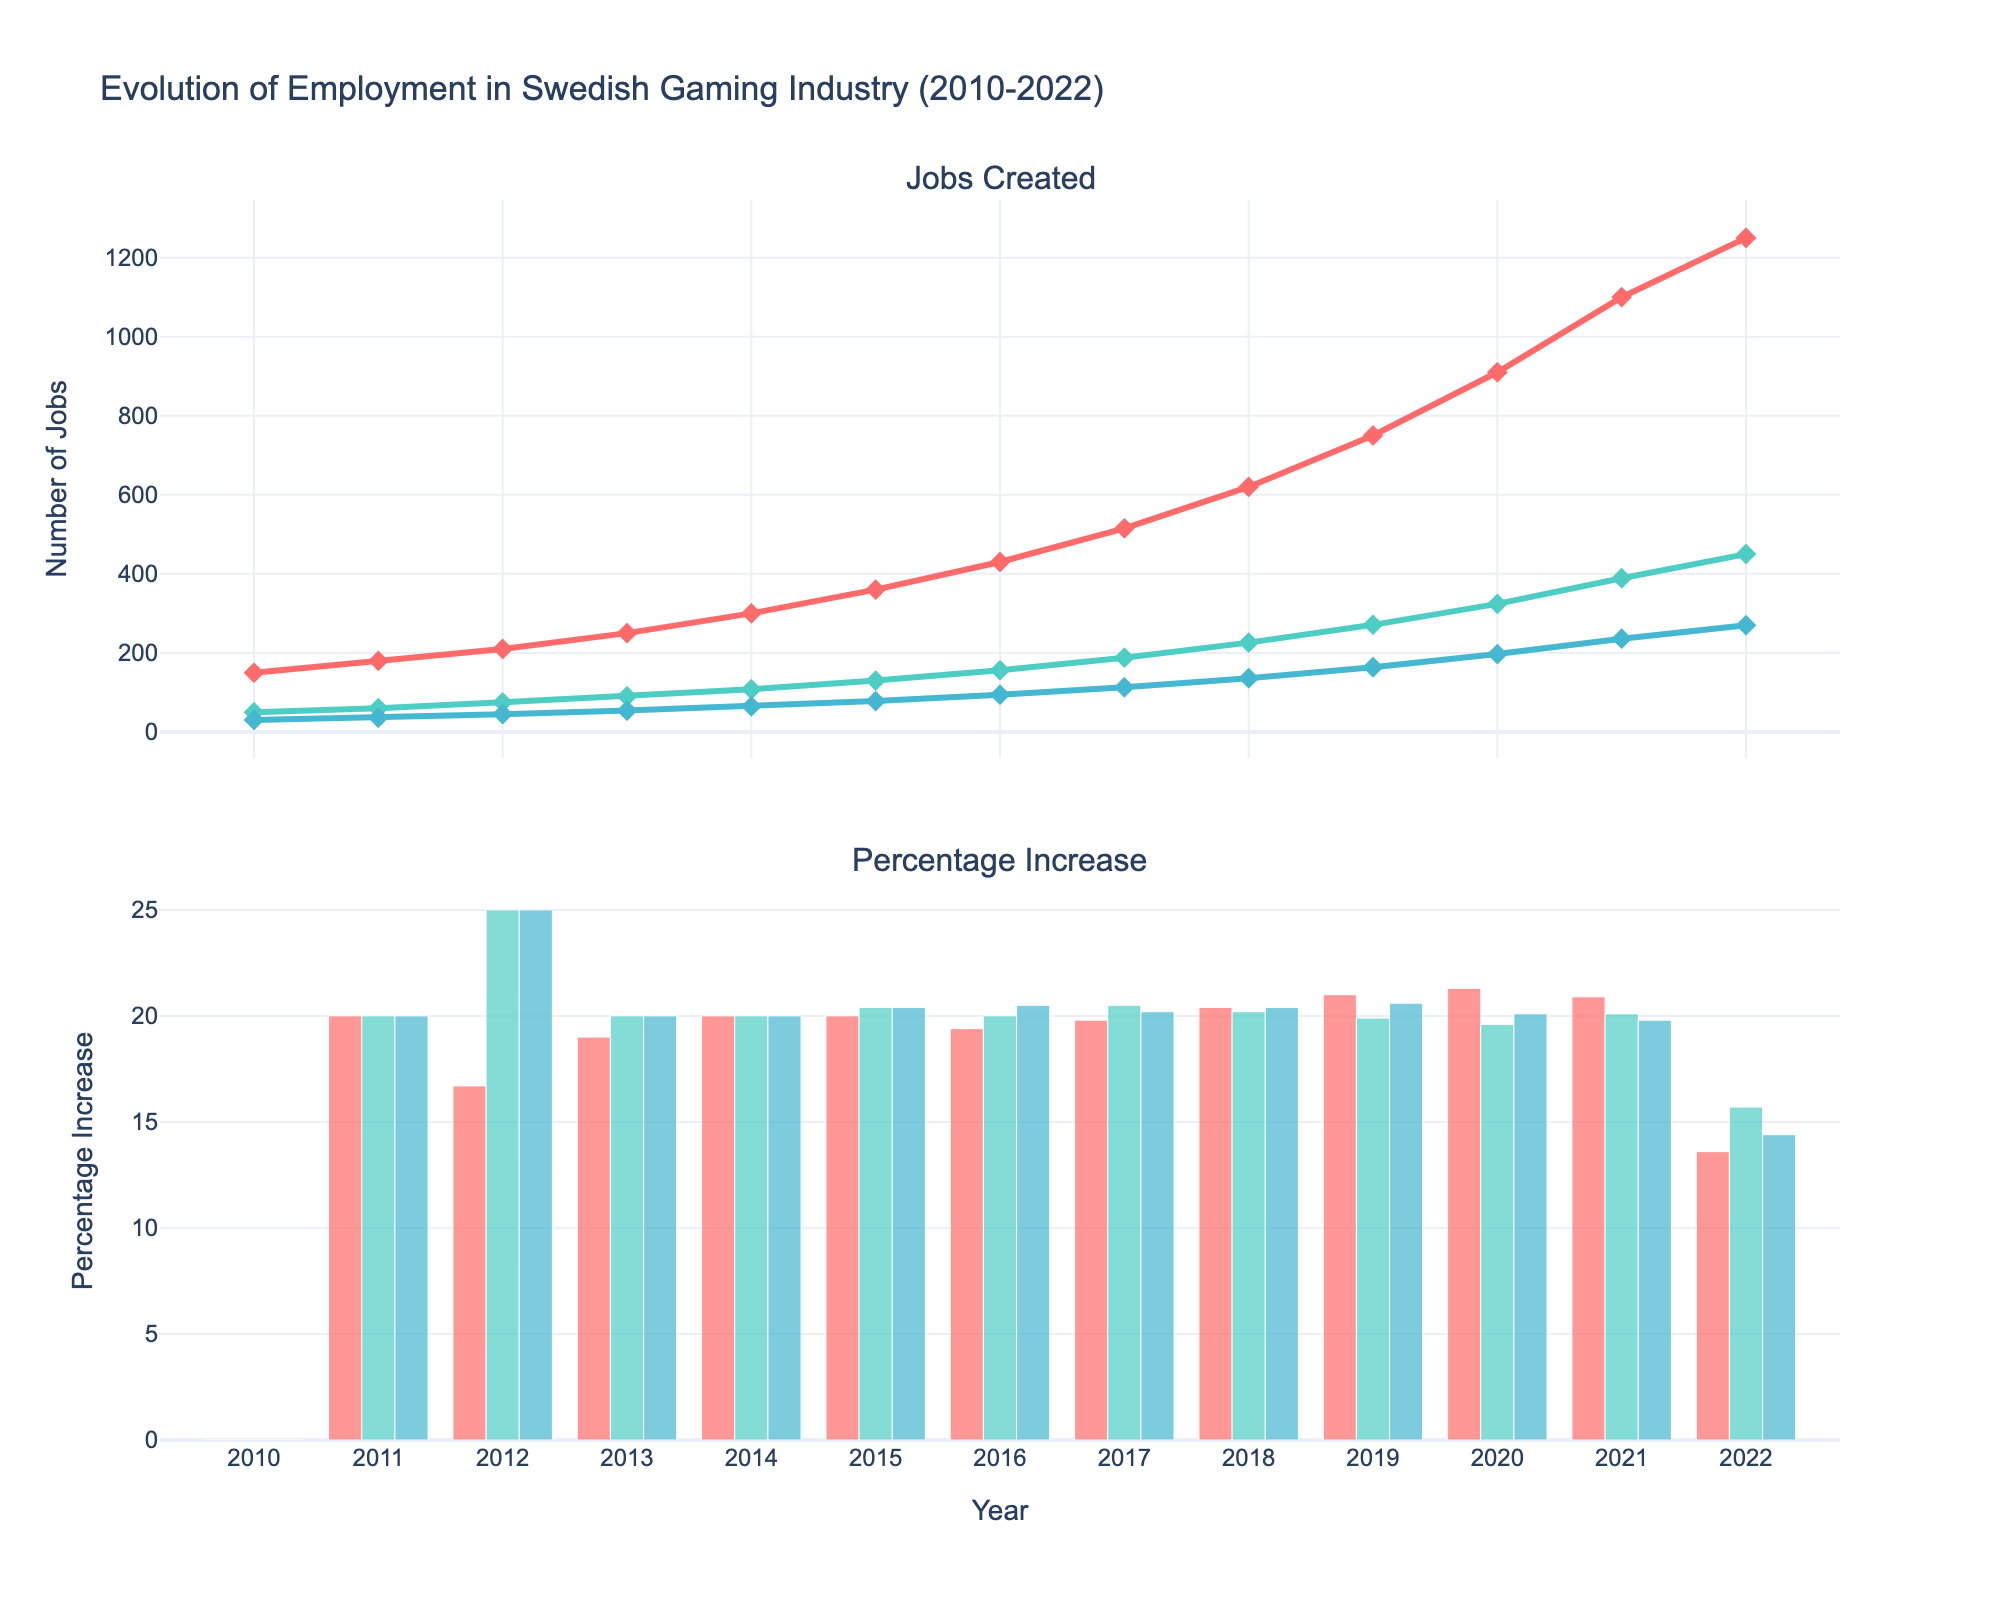What is the total number of jobs created for developers in 2020? In the figure, the jobs created for developers each year can be seen via the scatter plot on the top subplot. In 2020, the number of jobs created for developers is 910.
Answer: 910 Which role had the highest percentage increase in 2018? Comparing the bars for 2018 in the bottom subplot, the height of the bar indicates the percentage increase. The role with the highest bar in 2018 is the Developers, which had a percentage increase of 20.4%.
Answer: Developer What was the percentage increase for designers in 2015 and how does it compare to the percentage increase for artists in the same year? From the bar plot in the bottom subplot for 2015, the percentage increase for developers was 20.4%, whereas for artists it was 20.4%. Both roles had the same percentage increase.
Answer: Both are 20.4% How many jobs were created for designers during the entire period from 2010 to 2022? Sum the number of jobs created for designers each year from the scatter plot on the top subplot: 30 + 36 + 45 + 54 + 64.8 + 78 + 94 + 113 + 136 + 164 + 197 + 236 + 270 = 1,517.8
Answer: 1,517.8 Which year saw the largest percentage increase for developers, and what was that increase? Observing the bar plot in the bottom subplot for the developer role, the highest percentage bar for developers is in 2020, with an increase of 21.3%.
Answer: 2020, 21.3% Between 2015 and 2016, which role experienced the least growth in the number of jobs created? By comparing the scatter plots in the top subplot for the years 2015 and 2016, the increase for each role is calculated as follows: Developers: 430 - 360 = 70, Artists: 156 - 130 = 26, Designers: 94 - 78 = 16. Hence, Designers experienced the least growth with 16 jobs.
Answer: Designer What is the difference between the number of jobs created for developers in 2021 and 2022? From the scatter plot on the top subplot, the number of jobs created for developers in 2021 is 1100, and in 2022 is 1250. The difference is 1250 - 1100 = 150 jobs.
Answer: 150 